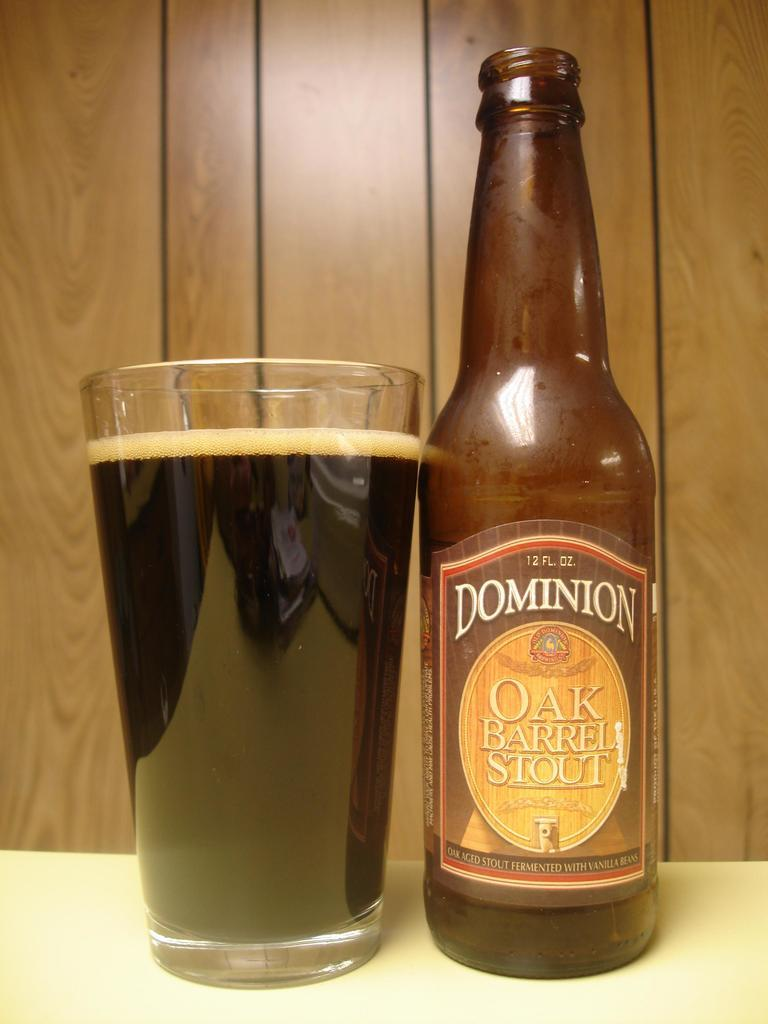<image>
Create a compact narrative representing the image presented. A glass of Dominioin Oak Barrel Stout next to the bottle it was poured from. 